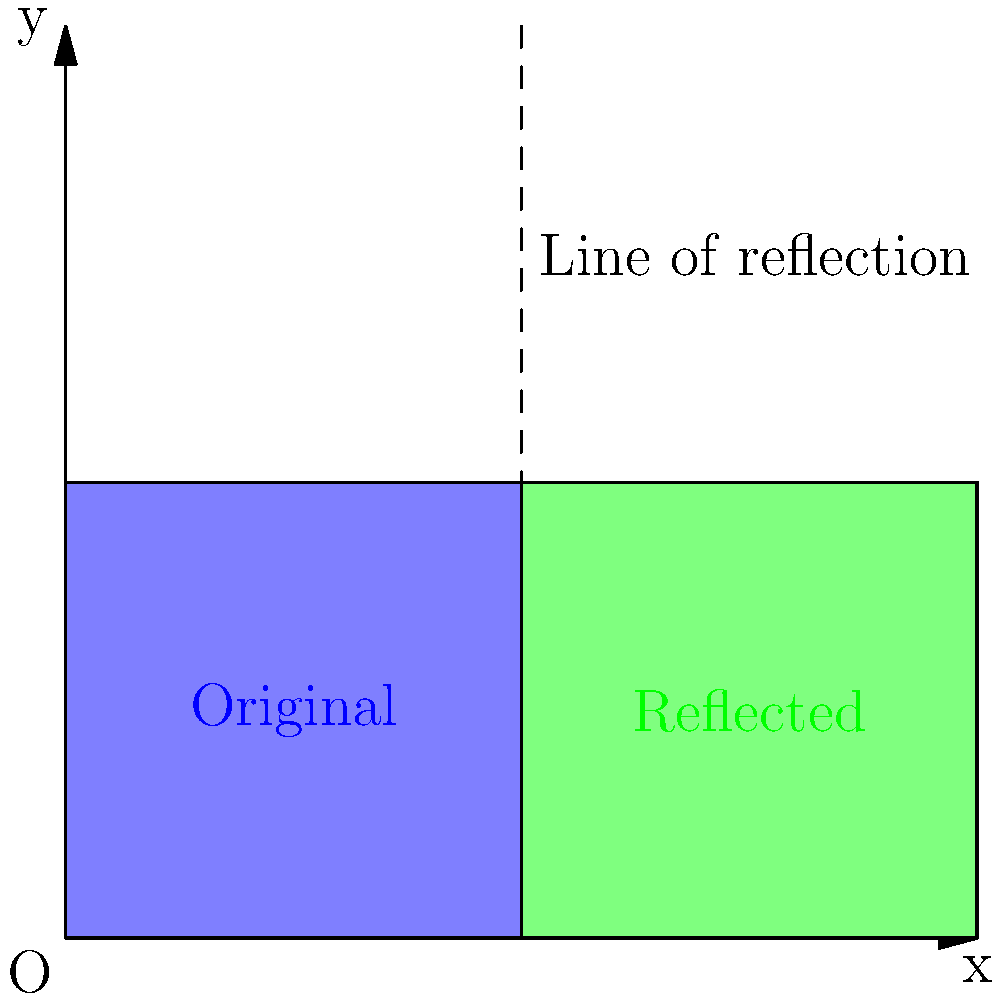In the analysis of traditional Laz textile patterns, a common motif is reflected across a vertical line to create symmetry. Given the coordinate transformation $T(x,y) = (2-x,y)$ that reflects a point across the line $x=1$, what would be the coordinates of point $P(0.75, 0.5)$ after this reflection? To find the coordinates of point $P$ after reflection, we need to apply the given transformation $T(x,y) = (2-x,y)$ to the original coordinates $(0.75, 0.5)$:

1) The x-coordinate transformation:
   $x_{new} = 2 - x_{original}$
   $x_{new} = 2 - 0.75 = 1.25$

2) The y-coordinate remains unchanged:
   $y_{new} = y_{original} = 0.5$

Therefore, after applying the reflection transformation, the new coordinates of point $P$ are $(1.25, 0.5)$.

This reflection creates a symmetrical pattern typical in Laz textiles, where motifs are often mirrored to create balance and harmony in the design. The line $x=1$ acts as the axis of symmetry in this transformation.
Answer: $(1.25, 0.5)$ 